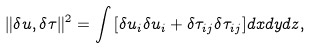Convert formula to latex. <formula><loc_0><loc_0><loc_500><loc_500>\| \delta u , \delta \tau \| ^ { 2 } = \int { [ \delta u _ { i } \delta u _ { i } + \delta \tau _ { i j } \delta \tau _ { i j } ] d x d y d z } ,</formula> 